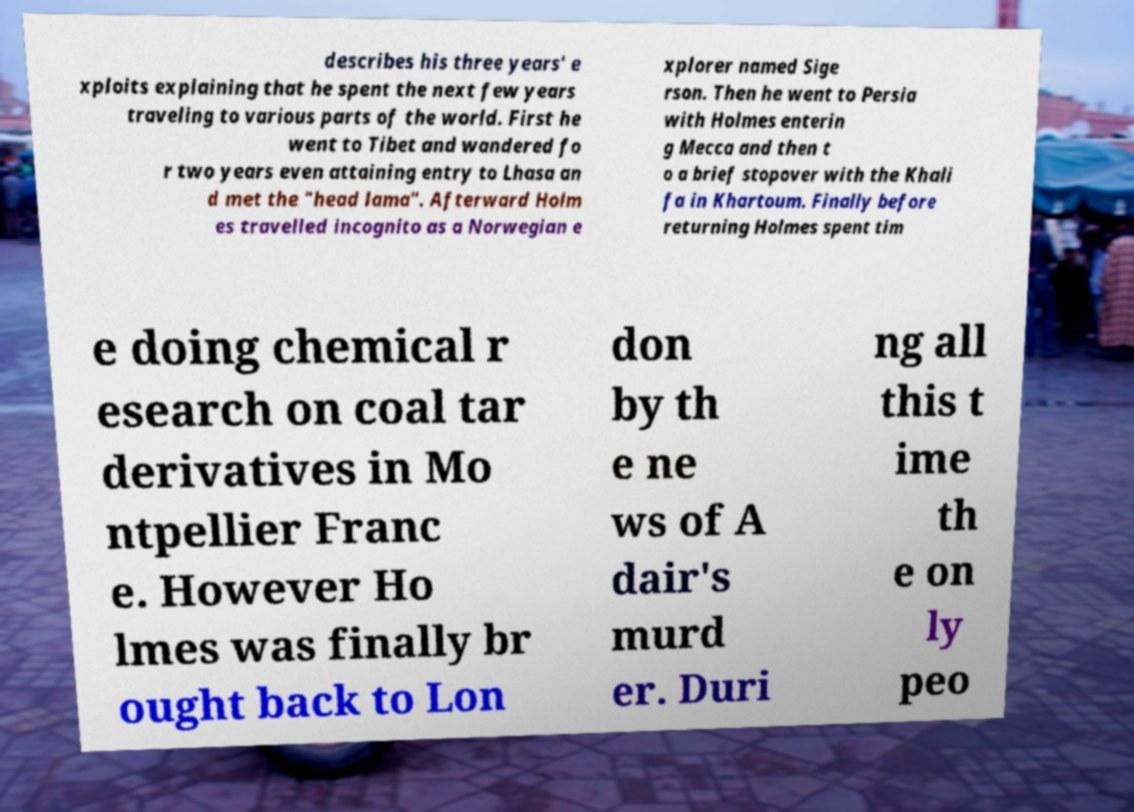Please read and relay the text visible in this image. What does it say? describes his three years' e xploits explaining that he spent the next few years traveling to various parts of the world. First he went to Tibet and wandered fo r two years even attaining entry to Lhasa an d met the "head lama". Afterward Holm es travelled incognito as a Norwegian e xplorer named Sige rson. Then he went to Persia with Holmes enterin g Mecca and then t o a brief stopover with the Khali fa in Khartoum. Finally before returning Holmes spent tim e doing chemical r esearch on coal tar derivatives in Mo ntpellier Franc e. However Ho lmes was finally br ought back to Lon don by th e ne ws of A dair's murd er. Duri ng all this t ime th e on ly peo 